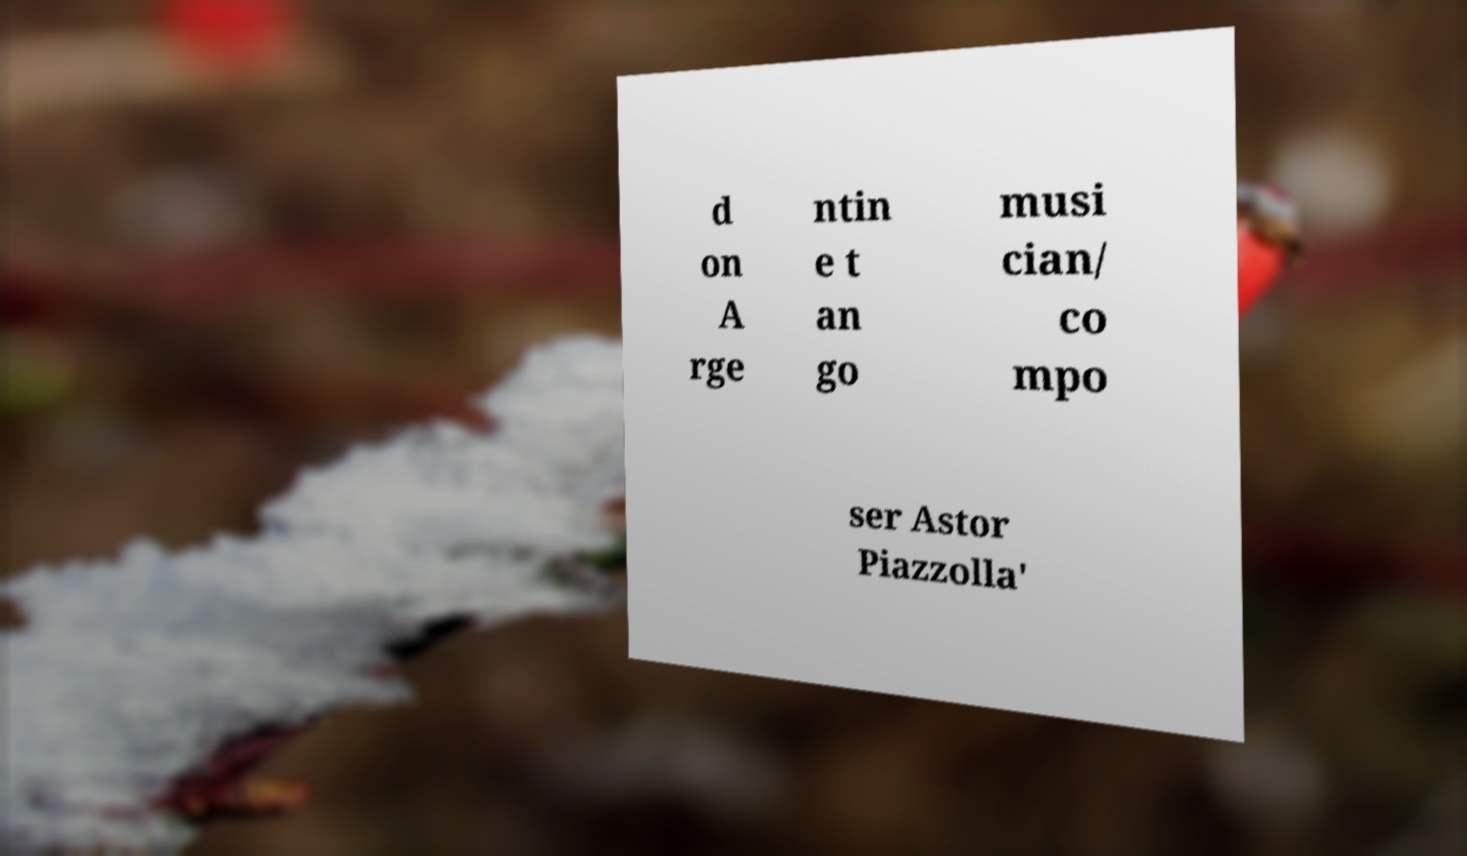Can you read and provide the text displayed in the image?This photo seems to have some interesting text. Can you extract and type it out for me? d on A rge ntin e t an go musi cian/ co mpo ser Astor Piazzolla' 